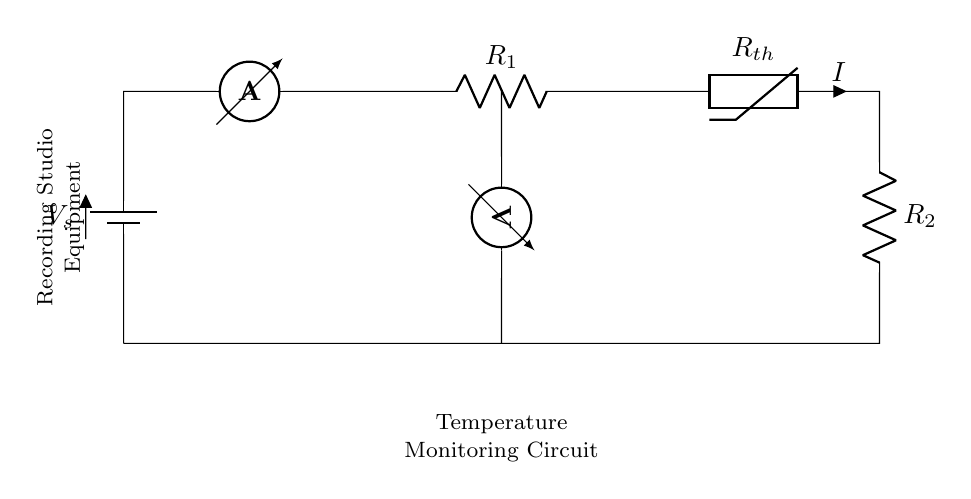what type of circuit is this? This circuit is a series circuit where components are connected end-to-end, creating a single pathway for current flow. The battery, ammeter, resistors, and thermistor are all arranged in this manner.
Answer: series circuit how many resistors are present in the circuit? In the diagram, there are two resistors. One is labeled as R1 and the other as R2. Both are in series with the thermistor, contributing to the total resistance.
Answer: two what is the purpose of the thermistor in this circuit? The thermistor is used to monitor temperature changes. Its resistance varies with temperature, impacting the current flow and voltage readings, which provides a means of temperature monitoring for the recording studio equipment.
Answer: temperature monitoring what is measured by the voltmeter in this circuit? The voltmeter measures the voltage drop across the thermistor, which is used to infer temperature based on its resistance properties. This measurement helps in determining how the temperature is affecting the circuit performance.
Answer: voltage drop across thermistor what does the ammeter measure in this circuit? The ammeter measures the current flowing through the circuit as it indicates the rate of electric charge passing through, which is affected by the total resistance of the circuit including the thermistor and resistors.
Answer: current flowing through the circuit why is a battery used in this circuit? The battery provides the necessary voltage to establish an electric potential difference, allowing current to flow through the series circuit. Without the battery, there would be no functioning circuit since components rely on this power source.
Answer: to provide voltage what happens to current if the temperature increases? If the temperature increases, the resistance of the thermistor generally decreases (if it's a negative temperature coefficient thermistor), leading to an increase in current in the series circuit due to reduced resistance.
Answer: current increases 